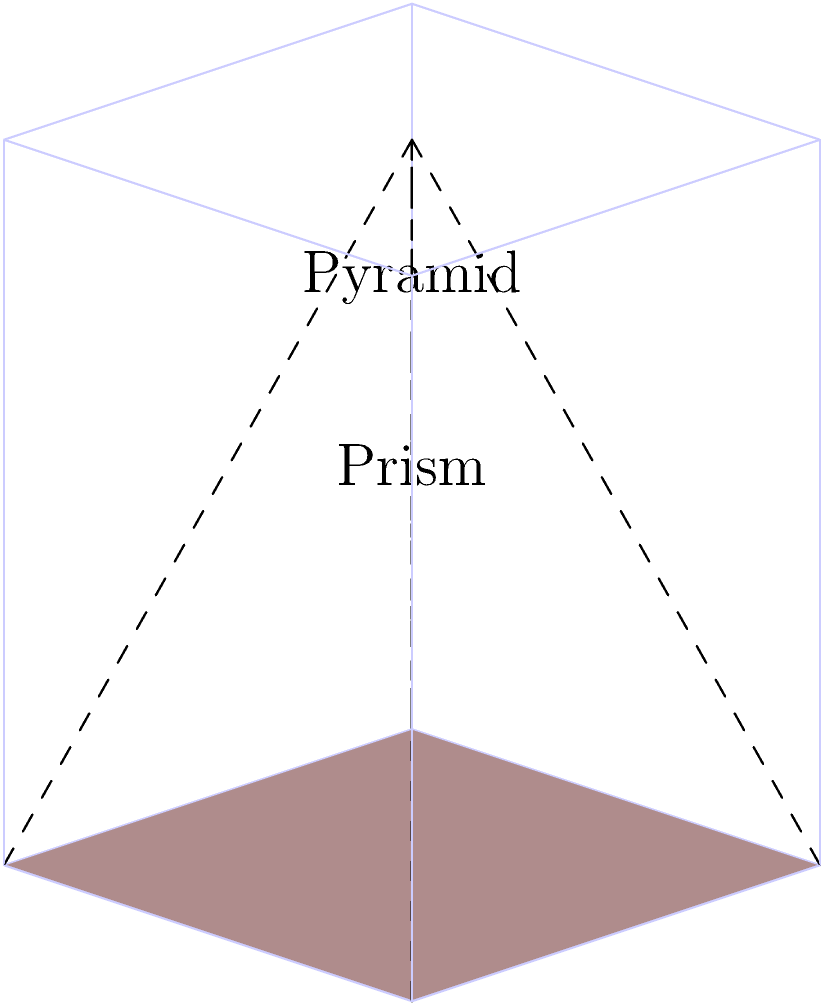Comrade, consider the relationship between the volume of a pyramid and its corresponding prism with the same base and height, as illustrated in the diagram. If we were to redistribute the material from the prism to form multiple identical pyramids, how many such pyramids could be created? Explain how this relates to the concept of equitable resource distribution in a socialist economy. Let's approach this step-by-step, comrade:

1) First, recall that the volume of a pyramid is given by the formula:

   $$V_p = \frac{1}{3} \times B \times h$$

   where $B$ is the area of the base and $h$ is the height.

2) The volume of a prism is given by:

   $$V_P = B \times h$$

3) Comparing these formulas, we can see that:

   $$V_P = 3 \times V_p$$

4) This means that the volume of the prism is exactly three times the volume of the pyramid with the same base and height.

5) Therefore, we could create exactly three identical pyramids from the material of one prism.

From a Marxist perspective, this relationship can be seen as an allegory for equitable resource distribution in a socialist economy:

- The prism represents the total resources available in society.
- The three identical pyramids represent an equal distribution of these resources among the members of society.
- Just as we can divide the prism's volume equally into three pyramids, a socialist system aims to divide societal resources equally among its members, ensuring that no one accumulates disproportionate wealth at the expense of others.

This geometric relationship thus serves as a powerful metaphor for the core principles of economic equality and fair distribution in Marxist theory.
Answer: 3 pyramids 